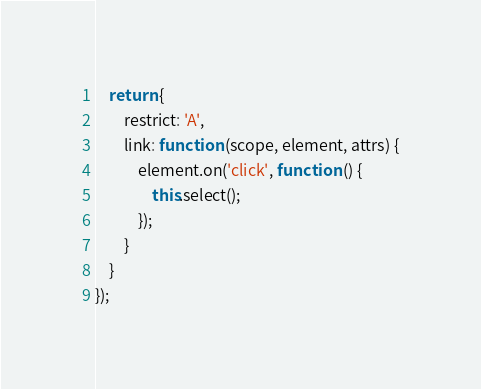Convert code to text. <code><loc_0><loc_0><loc_500><loc_500><_JavaScript_>    return {
        restrict: 'A',
        link: function (scope, element, attrs) {
            element.on('click', function () {
                this.select();
            });
        }
    }
});</code> 